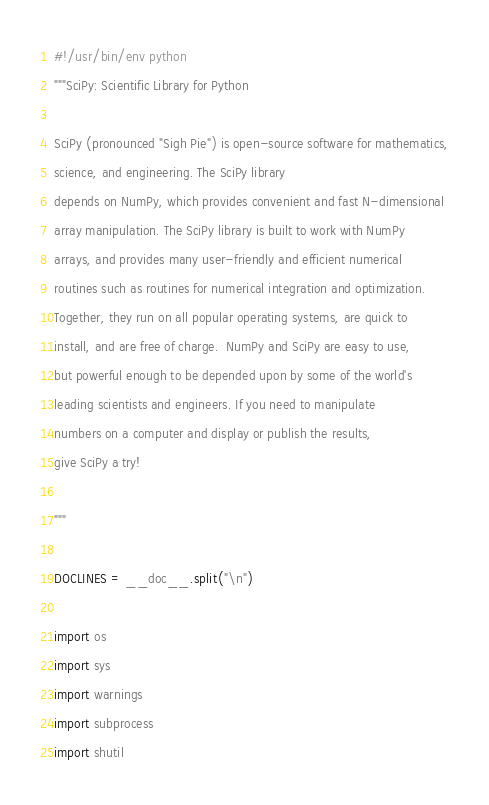Convert code to text. <code><loc_0><loc_0><loc_500><loc_500><_Python_>#!/usr/bin/env python
"""SciPy: Scientific Library for Python

SciPy (pronounced "Sigh Pie") is open-source software for mathematics,
science, and engineering. The SciPy library
depends on NumPy, which provides convenient and fast N-dimensional
array manipulation. The SciPy library is built to work with NumPy
arrays, and provides many user-friendly and efficient numerical
routines such as routines for numerical integration and optimization.
Together, they run on all popular operating systems, are quick to
install, and are free of charge.  NumPy and SciPy are easy to use,
but powerful enough to be depended upon by some of the world's
leading scientists and engineers. If you need to manipulate
numbers on a computer and display or publish the results,
give SciPy a try!

"""

DOCLINES = __doc__.split("\n")

import os
import sys
import warnings
import subprocess
import shutil</code> 